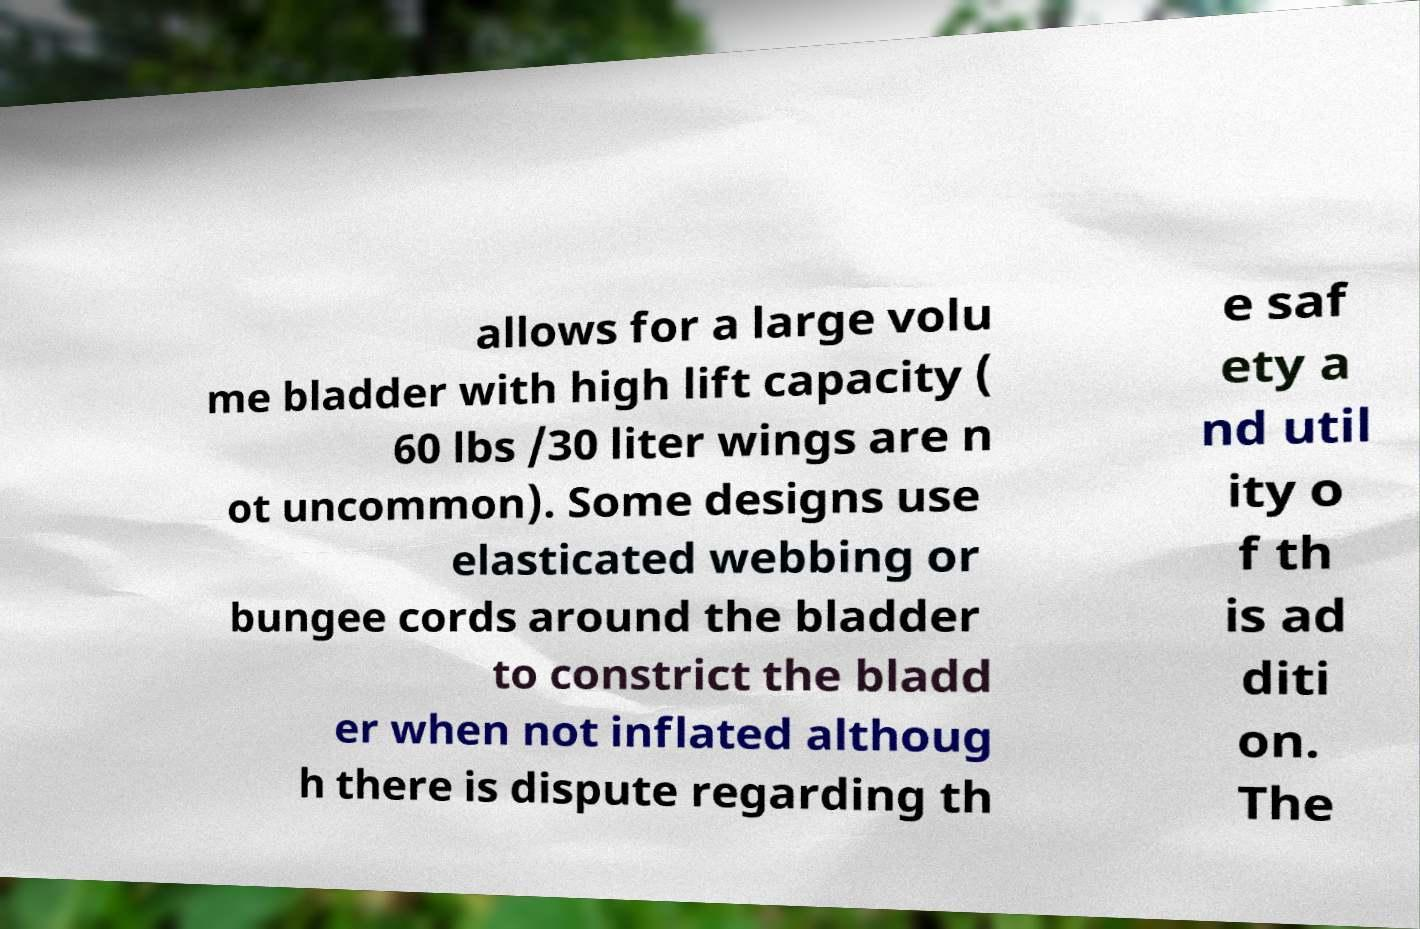There's text embedded in this image that I need extracted. Can you transcribe it verbatim? allows for a large volu me bladder with high lift capacity ( 60 lbs /30 liter wings are n ot uncommon). Some designs use elasticated webbing or bungee cords around the bladder to constrict the bladd er when not inflated althoug h there is dispute regarding th e saf ety a nd util ity o f th is ad diti on. The 